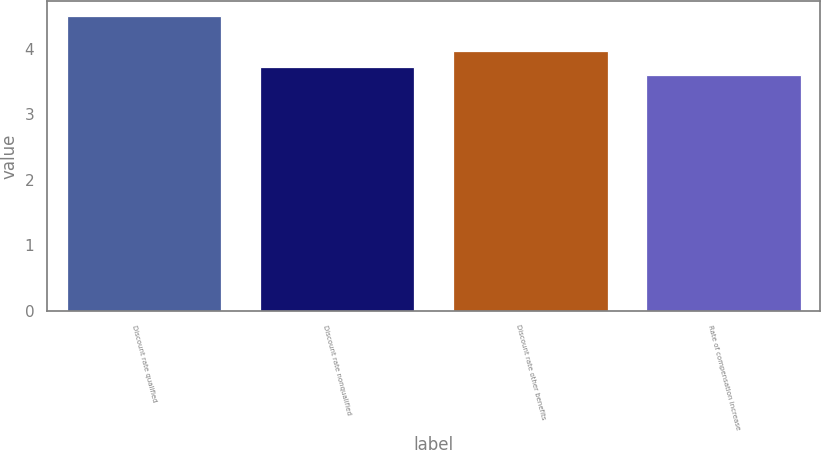Convert chart. <chart><loc_0><loc_0><loc_500><loc_500><bar_chart><fcel>Discount rate qualified<fcel>Discount rate nonqualified<fcel>Discount rate other benefits<fcel>Rate of compensation increase<nl><fcel>4.5<fcel>3.72<fcel>3.97<fcel>3.6<nl></chart> 